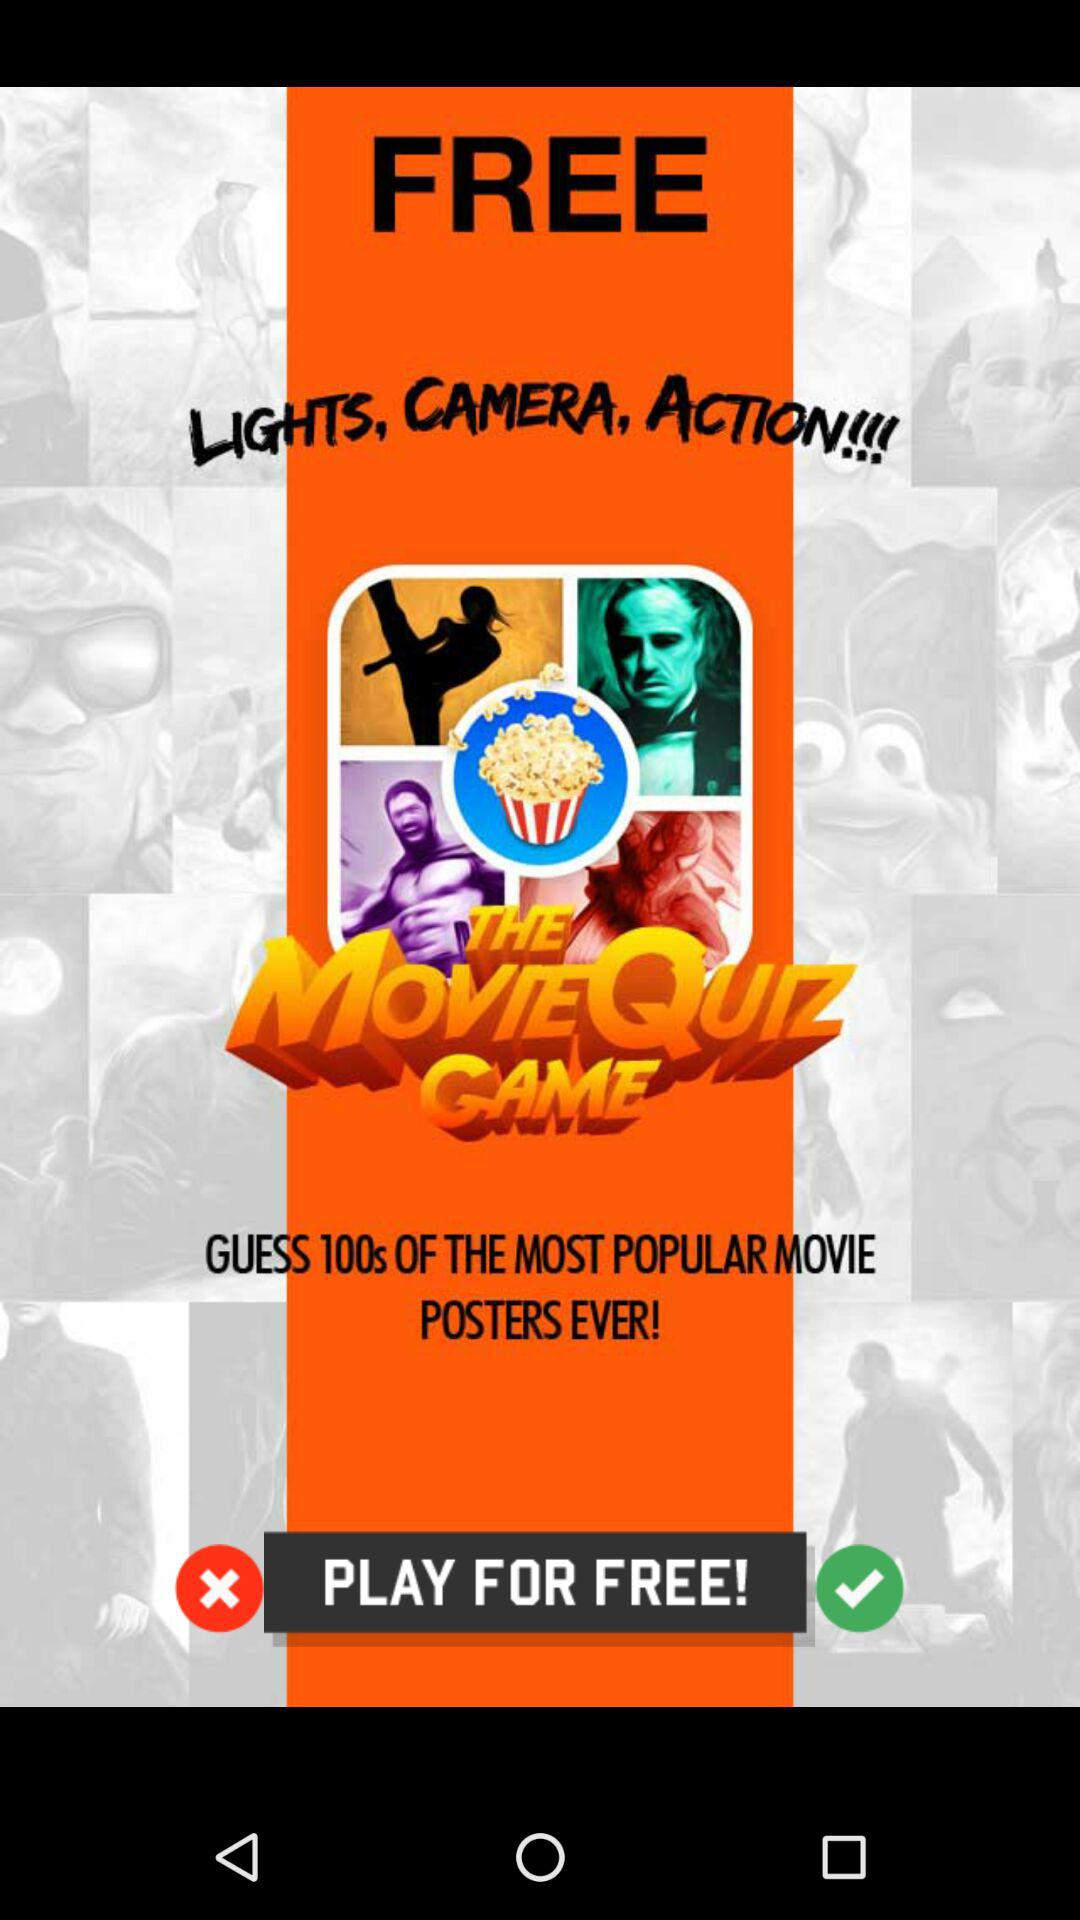What is the app name? The app name is "THE MovieQuiz GAME". 